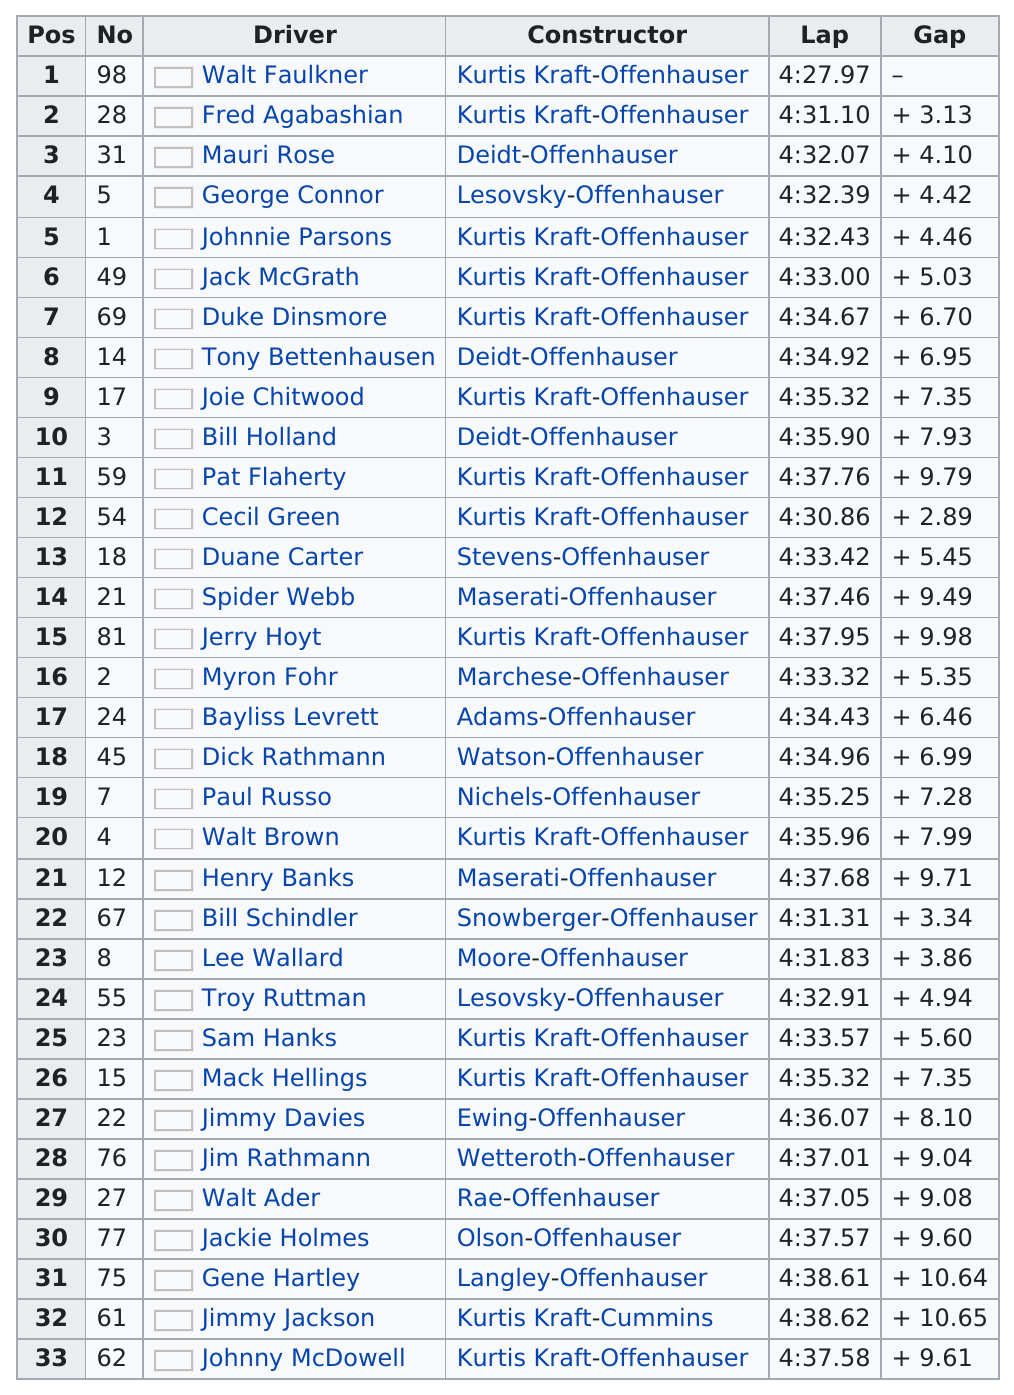Specify some key components in this picture. Jimmy Jackson has the largest gap among the qualifying drivers. Mauri Rose, the driver who used the deidt-offenhauser constructor, holds the record for having the highest position. 